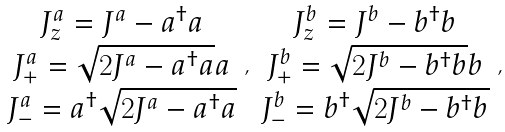Convert formula to latex. <formula><loc_0><loc_0><loc_500><loc_500>\begin{array} { c } J _ { z } ^ { a } = J ^ { a } - a ^ { \dagger } a \\ J _ { + } ^ { a } = \sqrt { 2 J ^ { a } - a ^ { \dagger } a } a \\ J _ { - } ^ { a } = a ^ { \dagger } \sqrt { 2 J ^ { a } - a ^ { \dagger } a } \end{array} , \begin{array} { c } J _ { z } ^ { b } = J ^ { b } - b ^ { \dagger } b \\ J _ { + } ^ { b } = \sqrt { 2 J ^ { b } - b ^ { \dagger } b } b \\ J _ { - } ^ { b } = b ^ { \dagger } \sqrt { 2 J ^ { b } - b ^ { \dagger } b } \end{array} ,</formula> 